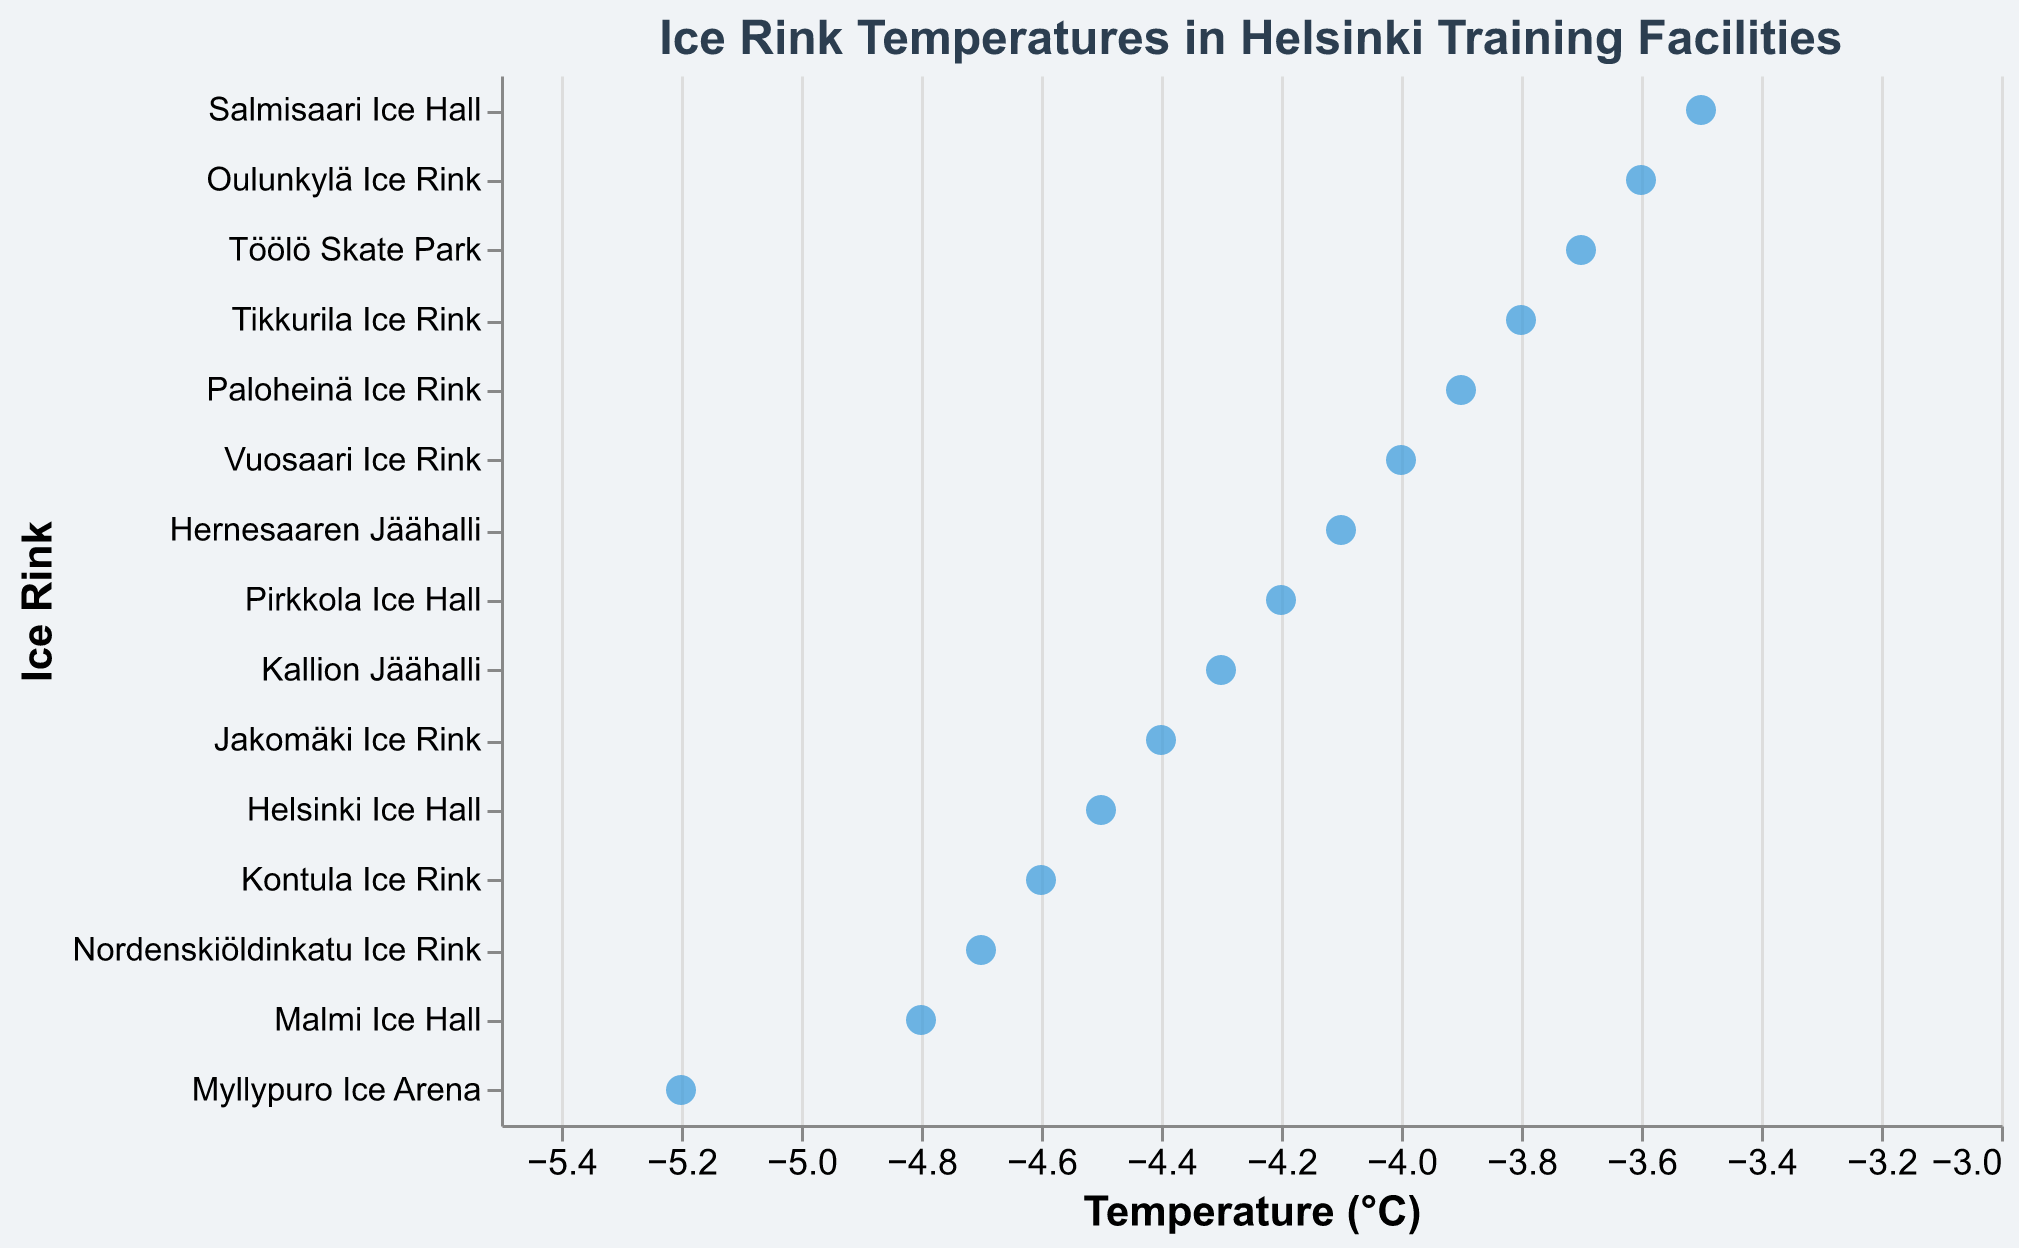What's the lowest temperature recorded among the ice rinks? By looking at the horizontal axis, we can identify the data point with the smallest value. The Myllypuro Ice Arena has the lowest temperature recorded.
Answer: -5.2°C Which ice rink has the highest temperature? The highest temperature is shown on the far right of the horizontal axis. Salmisaari Ice Hall has the highest temperature.
Answer: -3.5°C How many ice rinks have temperatures warmer than -4.0°C? The ice rinks with temperatures warmer than -4.0°C are to the right of the -4.0°C mark on the horizontal axis. There are five such rinks: Tikkurila Ice Rink, Oulunkylä Ice Rink, Paloheinä Ice Rink, Töölö Skate Park, and Salmisaari Ice Hall.
Answer: 5 What is the average temperature of all the ice rinks? To find the average temperature, sum all the temperature values and then divide by the number of ice rinks: (-4.5 - 3.8 - 5.2 - 4.2 - 3.6 - 4.8 - 4.0 - 3.9 - 4.3 - 4.7 - 4.1 - 3.7 - 4.4 - 4.6 - 3.5) / 15 = -4.19°C.
Answer: -4.19°C Are there any ice rinks with the same temperature? We check if there are overlapping points vertically on the strip plot. None of the points overlap vertically, indicating each ice rink has a unique temperature.
Answer: No Which ice rinks fall within the temperature range of -4.0°C to -4.5°C? Consider points between -4.5°C and -4.0°C on the horizontal axis. The ice rinks within this range are Helsinki Ice Hall, Pirkkola Ice Hall, Vuosaari Ice Rink, Kallion Jäähalli, Hernesaaren Jäähalli, and Jakomäki Ice Rink.
Answer: Helsinki Ice Hall, Pirkkola Ice Hall, Vuosaari Ice Rink, Kallion Jäähalli, Hernesaaren Jäähalli, Jakomäki Ice Rink What is the temperature difference between the warmest and coldest ice rinks? The temperature difference is calculated by subtracting the lowest temperature from the highest temperature: -3.5°C (Salmisaari Ice Hall) - (-5.2°C (Myllypuro Ice Arena)) = 1.7°C.
Answer: 1.7°C Which ice rink is closest to the average temperature? Calculating the absolute difference between the average temperature (-4.19°C) and each ice rink's temperature, we find that Kallion Jäähalli with a temperature of -4.3°C is closest to the average.
Answer: Kallion Jäähalli 